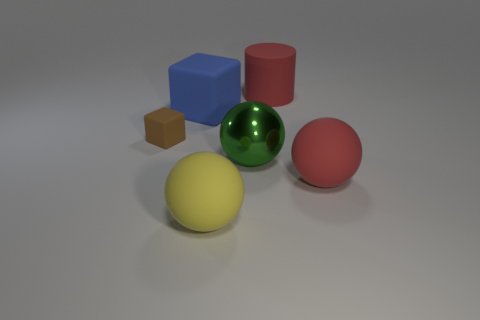Subtract all red spheres. How many spheres are left? 2 Add 3 small purple cubes. How many objects exist? 9 Subtract 1 spheres. How many spheres are left? 2 Subtract all cylinders. How many objects are left? 5 Add 4 big red cylinders. How many big red cylinders exist? 5 Subtract 0 cyan blocks. How many objects are left? 6 Subtract all metal objects. Subtract all metal balls. How many objects are left? 4 Add 3 yellow objects. How many yellow objects are left? 4 